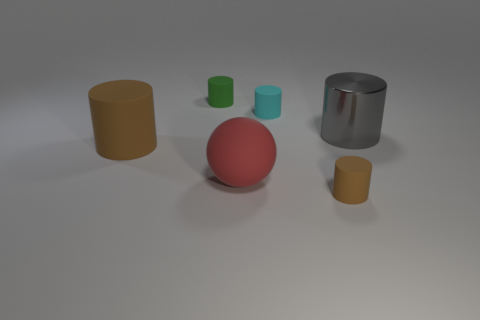Is there any other thing that is the same material as the gray thing?
Provide a short and direct response. No. There is a brown thing that is to the left of the tiny rubber thing that is in front of the shiny cylinder; what is it made of?
Provide a succinct answer. Rubber. Is the size of the gray shiny cylinder the same as the brown cylinder behind the big red sphere?
Provide a short and direct response. Yes. Is there a big thing of the same color as the sphere?
Ensure brevity in your answer.  No. What number of large objects are either matte cylinders or cylinders?
Offer a terse response. 2. What number of large cyan rubber cylinders are there?
Provide a succinct answer. 0. What material is the tiny cylinder in front of the large brown matte thing?
Make the answer very short. Rubber. Are there any small matte things to the right of the gray metallic thing?
Keep it short and to the point. No. Is the size of the gray metal cylinder the same as the matte ball?
Your answer should be very brief. Yes. How many large brown cylinders have the same material as the tiny green cylinder?
Your answer should be very brief. 1. 